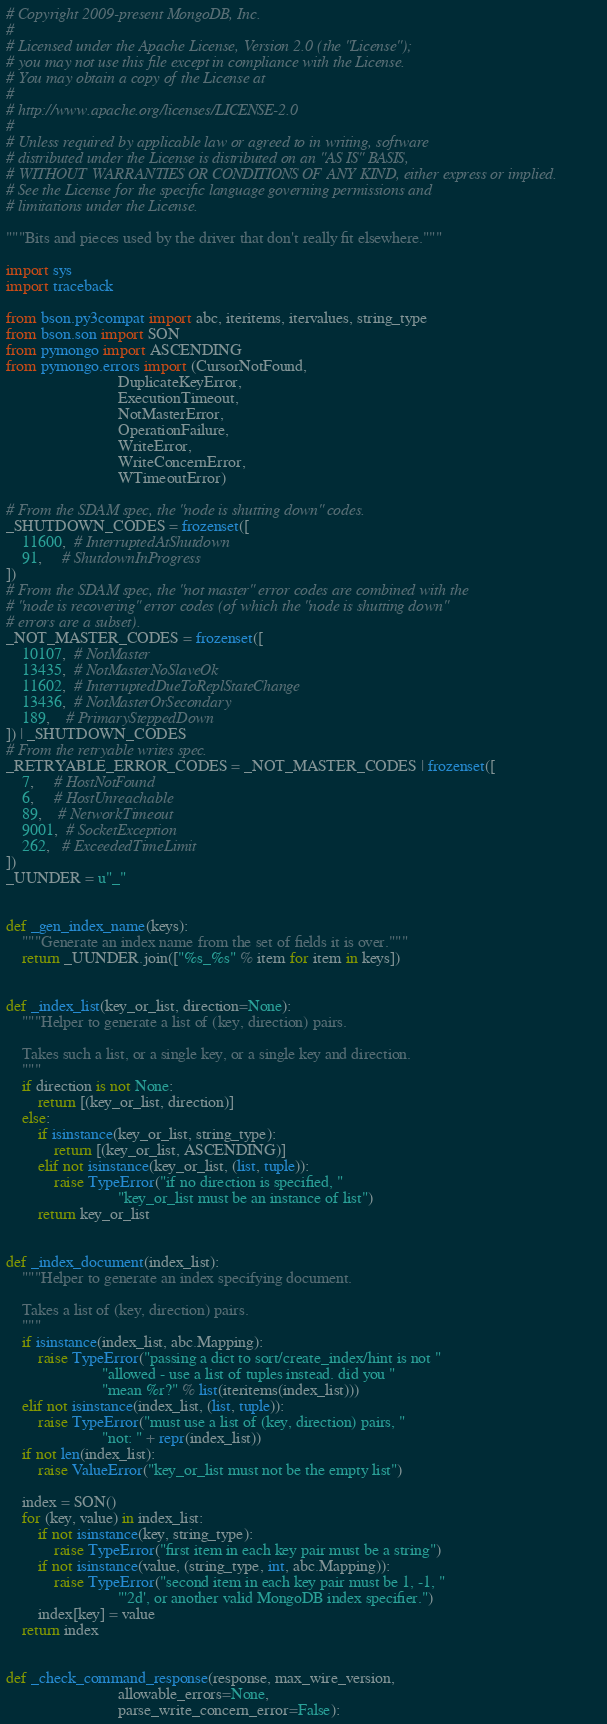Convert code to text. <code><loc_0><loc_0><loc_500><loc_500><_Python_># Copyright 2009-present MongoDB, Inc.
#
# Licensed under the Apache License, Version 2.0 (the "License");
# you may not use this file except in compliance with the License.
# You may obtain a copy of the License at
#
# http://www.apache.org/licenses/LICENSE-2.0
#
# Unless required by applicable law or agreed to in writing, software
# distributed under the License is distributed on an "AS IS" BASIS,
# WITHOUT WARRANTIES OR CONDITIONS OF ANY KIND, either express or implied.
# See the License for the specific language governing permissions and
# limitations under the License.

"""Bits and pieces used by the driver that don't really fit elsewhere."""

import sys
import traceback

from bson.py3compat import abc, iteritems, itervalues, string_type
from bson.son import SON
from pymongo import ASCENDING
from pymongo.errors import (CursorNotFound,
                            DuplicateKeyError,
                            ExecutionTimeout,
                            NotMasterError,
                            OperationFailure,
                            WriteError,
                            WriteConcernError,
                            WTimeoutError)

# From the SDAM spec, the "node is shutting down" codes.
_SHUTDOWN_CODES = frozenset([
    11600,  # InterruptedAtShutdown
    91,     # ShutdownInProgress
])
# From the SDAM spec, the "not master" error codes are combined with the
# "node is recovering" error codes (of which the "node is shutting down"
# errors are a subset).
_NOT_MASTER_CODES = frozenset([
    10107,  # NotMaster
    13435,  # NotMasterNoSlaveOk
    11602,  # InterruptedDueToReplStateChange
    13436,  # NotMasterOrSecondary
    189,    # PrimarySteppedDown
]) | _SHUTDOWN_CODES
# From the retryable writes spec.
_RETRYABLE_ERROR_CODES = _NOT_MASTER_CODES | frozenset([
    7,     # HostNotFound
    6,     # HostUnreachable
    89,    # NetworkTimeout
    9001,  # SocketException
    262,   # ExceededTimeLimit
])
_UUNDER = u"_"


def _gen_index_name(keys):
    """Generate an index name from the set of fields it is over."""
    return _UUNDER.join(["%s_%s" % item for item in keys])


def _index_list(key_or_list, direction=None):
    """Helper to generate a list of (key, direction) pairs.

    Takes such a list, or a single key, or a single key and direction.
    """
    if direction is not None:
        return [(key_or_list, direction)]
    else:
        if isinstance(key_or_list, string_type):
            return [(key_or_list, ASCENDING)]
        elif not isinstance(key_or_list, (list, tuple)):
            raise TypeError("if no direction is specified, "
                            "key_or_list must be an instance of list")
        return key_or_list


def _index_document(index_list):
    """Helper to generate an index specifying document.

    Takes a list of (key, direction) pairs.
    """
    if isinstance(index_list, abc.Mapping):
        raise TypeError("passing a dict to sort/create_index/hint is not "
                        "allowed - use a list of tuples instead. did you "
                        "mean %r?" % list(iteritems(index_list)))
    elif not isinstance(index_list, (list, tuple)):
        raise TypeError("must use a list of (key, direction) pairs, "
                        "not: " + repr(index_list))
    if not len(index_list):
        raise ValueError("key_or_list must not be the empty list")

    index = SON()
    for (key, value) in index_list:
        if not isinstance(key, string_type):
            raise TypeError("first item in each key pair must be a string")
        if not isinstance(value, (string_type, int, abc.Mapping)):
            raise TypeError("second item in each key pair must be 1, -1, "
                            "'2d', or another valid MongoDB index specifier.")
        index[key] = value
    return index


def _check_command_response(response, max_wire_version,
                            allowable_errors=None,
                            parse_write_concern_error=False):</code> 